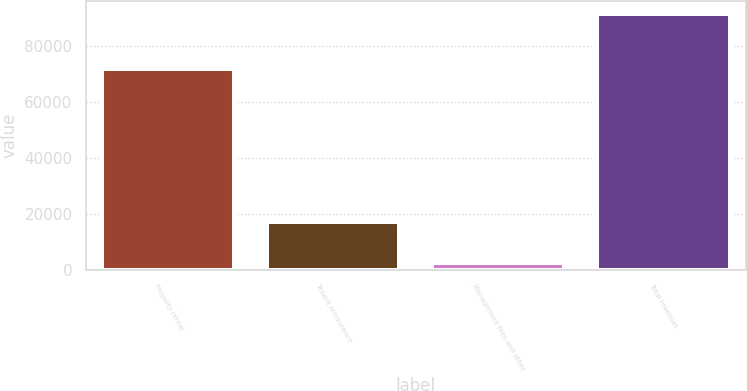<chart> <loc_0><loc_0><loc_500><loc_500><bar_chart><fcel>Property rental<fcel>Tenant reinsurance<fcel>Management fees and other<fcel>Total revenues<nl><fcel>72111<fcel>17106<fcel>2378<fcel>91595<nl></chart> 